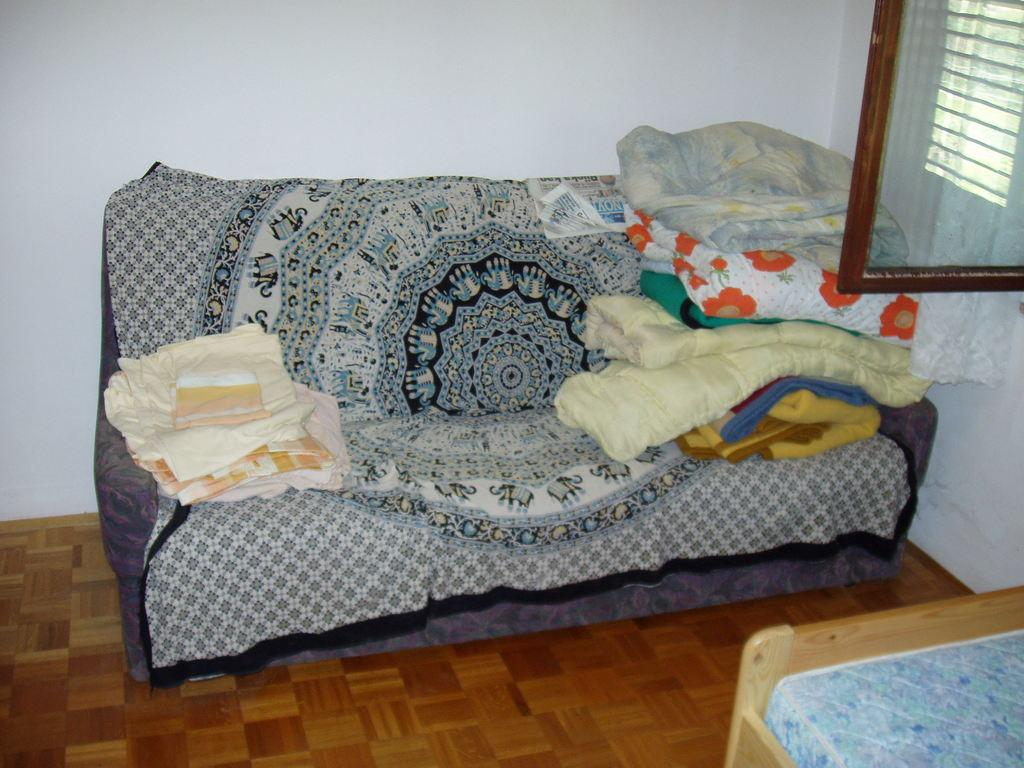What is the color of the wall in the image? The wall in the image is white. What can be seen on the wall in the image? There is a window on the wall in the image. What type of furniture is present in the image? There is a sofa and a table in the image. What type of fabric is visible in the image? There are bed sheets in the image. What type of meat is being taught to play music in the image? There is no meat or musical instrument present in the image. 